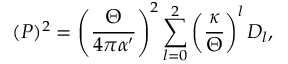Convert formula to latex. <formula><loc_0><loc_0><loc_500><loc_500>( P ) ^ { 2 } = \left ( { \frac { \Theta } { 4 \pi \alpha ^ { \prime } } } \right ) ^ { 2 } \sum _ { l = 0 } ^ { 2 } \left ( \frac { \kappa } { \Theta } \right ) ^ { l } D _ { l } ,</formula> 